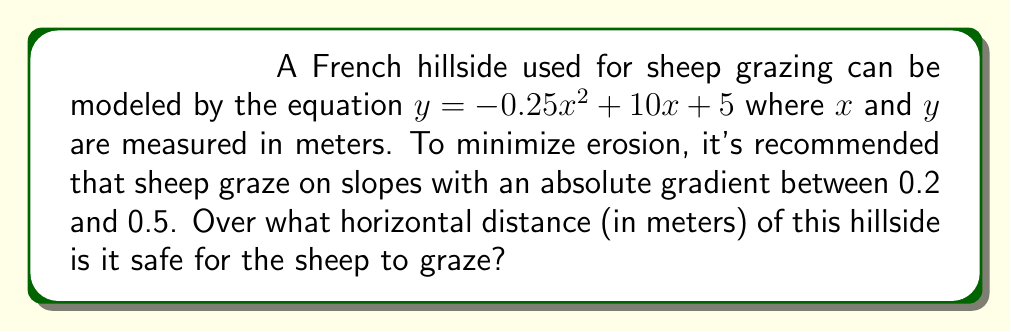Solve this math problem. Let's approach this step-by-step:

1) The slope of a curve at any point is given by its derivative. Let's find the derivative of the given function:

   $y = -0.25x^2 + 10x + 5$
   $\frac{dy}{dx} = -0.5x + 10$

2) We need to find where the absolute value of this slope is between 0.2 and 0.5:

   $0.2 \leq |-0.5x + 10| \leq 0.5$

3) Let's solve each inequality:

   For $|-0.5x + 10| \geq 0.2$:
   $-0.5x + 10 \geq 0.2$ or $-0.5x + 10 \leq -0.2$
   $-0.5x \geq -9.8$ or $-0.5x \leq -10.2$
   $x \leq 19.6$ or $x \geq 20.4$

   For $|-0.5x + 10| \leq 0.5$:
   $-0.5 \leq -0.5x + 10 \leq 0.5$
   $-10.5 \leq -0.5x \leq -9.5$
   $21 \geq x \geq 19$

4) Combining these inequalities, we get:
   $19.6 \geq x \geq 19$ and $20.4 \leq x \leq 21$

5) This means there are two ranges where grazing is safe:
   From 19 to 19.6 meters, and from 20.4 to 21 meters.

6) The total horizontal distance is:
   $(19.6 - 19) + (21 - 20.4) = 0.6 + 0.6 = 1.2$ meters

Therefore, it is safe for sheep to graze over a total horizontal distance of 1.2 meters on this hillside.
Answer: 1.2 meters 